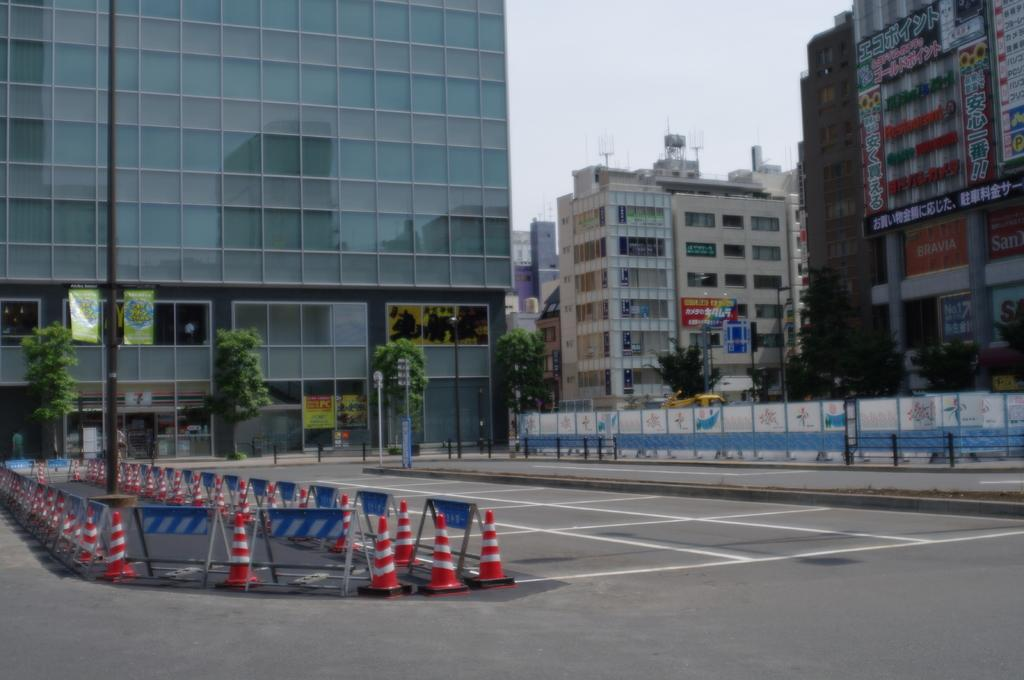What is located in the center of the image? There are buildings in the center of the image. What type of natural elements can be seen in the image? There are trees in the image. What type of man-made structure is visible in the image? There is a road in the image. What objects are present to ensure safety in the image? There are safety cones in the image. What type of fowl can be seen interacting with the safety cones in the image? There is no fowl present in the image; it only features buildings, trees, a road, and safety cones. What type of medical advice can be heard from the doctor in the image? There is no doctor present in the image, and therefore no medical advice can be heard. 